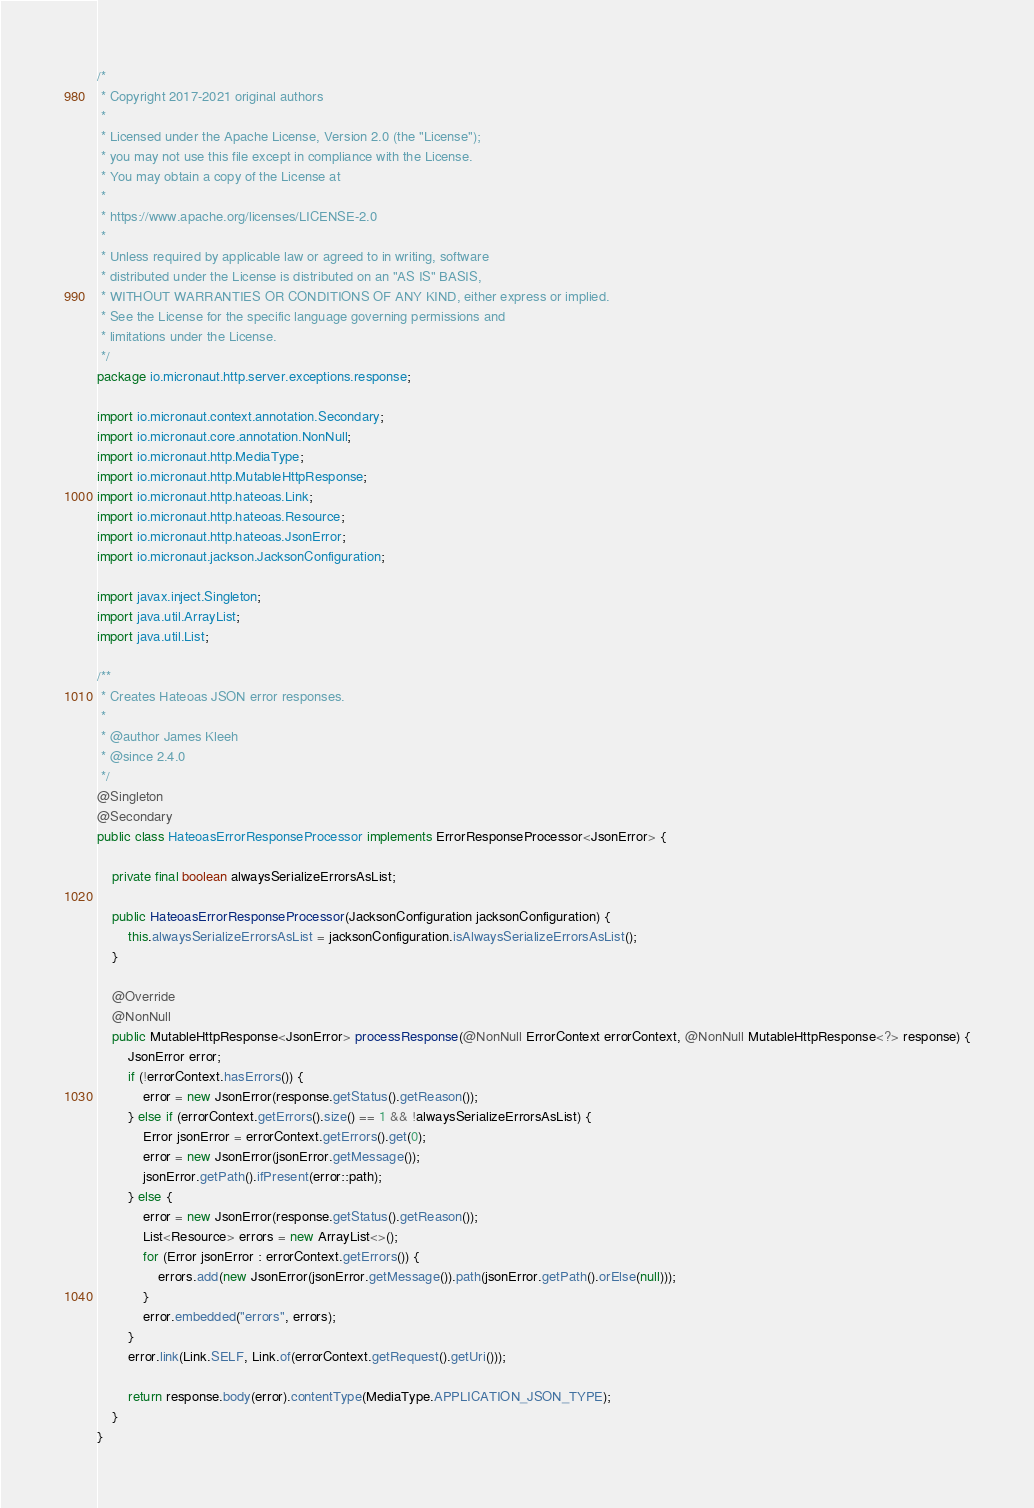Convert code to text. <code><loc_0><loc_0><loc_500><loc_500><_Java_>/*
 * Copyright 2017-2021 original authors
 *
 * Licensed under the Apache License, Version 2.0 (the "License");
 * you may not use this file except in compliance with the License.
 * You may obtain a copy of the License at
 *
 * https://www.apache.org/licenses/LICENSE-2.0
 *
 * Unless required by applicable law or agreed to in writing, software
 * distributed under the License is distributed on an "AS IS" BASIS,
 * WITHOUT WARRANTIES OR CONDITIONS OF ANY KIND, either express or implied.
 * See the License for the specific language governing permissions and
 * limitations under the License.
 */
package io.micronaut.http.server.exceptions.response;

import io.micronaut.context.annotation.Secondary;
import io.micronaut.core.annotation.NonNull;
import io.micronaut.http.MediaType;
import io.micronaut.http.MutableHttpResponse;
import io.micronaut.http.hateoas.Link;
import io.micronaut.http.hateoas.Resource;
import io.micronaut.http.hateoas.JsonError;
import io.micronaut.jackson.JacksonConfiguration;

import javax.inject.Singleton;
import java.util.ArrayList;
import java.util.List;

/**
 * Creates Hateoas JSON error responses.
 *
 * @author James Kleeh
 * @since 2.4.0
 */
@Singleton
@Secondary
public class HateoasErrorResponseProcessor implements ErrorResponseProcessor<JsonError> {

    private final boolean alwaysSerializeErrorsAsList;

    public HateoasErrorResponseProcessor(JacksonConfiguration jacksonConfiguration) {
        this.alwaysSerializeErrorsAsList = jacksonConfiguration.isAlwaysSerializeErrorsAsList();
    }

    @Override
    @NonNull
    public MutableHttpResponse<JsonError> processResponse(@NonNull ErrorContext errorContext, @NonNull MutableHttpResponse<?> response) {
        JsonError error;
        if (!errorContext.hasErrors()) {
            error = new JsonError(response.getStatus().getReason());
        } else if (errorContext.getErrors().size() == 1 && !alwaysSerializeErrorsAsList) {
            Error jsonError = errorContext.getErrors().get(0);
            error = new JsonError(jsonError.getMessage());
            jsonError.getPath().ifPresent(error::path);
        } else {
            error = new JsonError(response.getStatus().getReason());
            List<Resource> errors = new ArrayList<>();
            for (Error jsonError : errorContext.getErrors()) {
                errors.add(new JsonError(jsonError.getMessage()).path(jsonError.getPath().orElse(null)));
            }
            error.embedded("errors", errors);
        }
        error.link(Link.SELF, Link.of(errorContext.getRequest().getUri()));

        return response.body(error).contentType(MediaType.APPLICATION_JSON_TYPE);
    }
}
</code> 